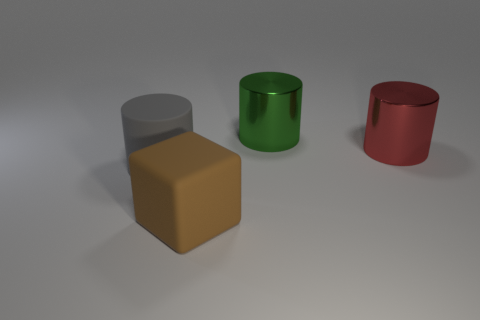What is the color of the large rubber object that is left of the large block? The large rubber object positioned to the left of the prominent block is green. 